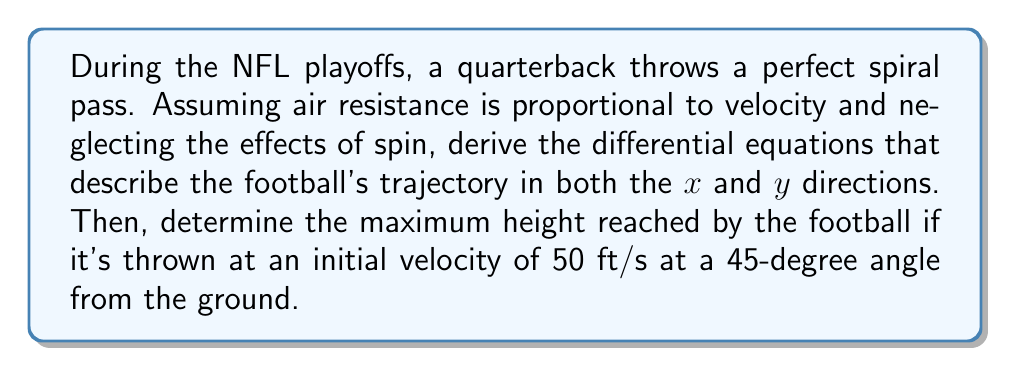What is the answer to this math problem? Let's approach this step-by-step:

1) First, we need to set up our coordinate system. Let's use x for horizontal distance and y for vertical distance.

2) The forces acting on the football are gravity (mg) downward and air resistance (kv) opposite to the direction of motion.

3) We can split the air resistance into x and y components:
   $F_x = -kv_x$ and $F_y = -kv_y - mg$

4) Using Newton's second law (F = ma), we can write our differential equations:

   For x-direction: $m\frac{d^2x}{dt^2} = -kv_x = -k\frac{dx}{dt}$
   
   For y-direction: $m\frac{d^2y}{dt^2} = -kv_y - mg = -k\frac{dy}{dt} - mg$

5) To find the maximum height, we need to solve the y-direction equation. At the highest point, $\frac{dy}{dt} = 0$.

6) The initial velocity components are:
   $v_{x0} = v_0 \cos(45°) = 50 \cdot \frac{\sqrt{2}}{2} \approx 35.36$ ft/s
   $v_{y0} = v_0 \sin(45°) = 50 \cdot \frac{\sqrt{2}}{2} \approx 35.36$ ft/s

7) The y-direction equation can be solved as:

   $y(t) = \frac{mg}{k}t + \frac{m}{k}(v_{y0} + \frac{mg}{k})(1 - e^{-\frac{k}{m}t})$

8) To find the maximum height, we need to find when $\frac{dy}{dt} = 0$:

   $\frac{dy}{dt} = \frac{mg}{k} + (v_{y0} + \frac{mg}{k})e^{-\frac{k}{m}t} = 0$

9) Solving this:

   $t_{max} = \frac{m}{k}\ln(1 + \frac{kv_{y0}}{mg})$

10) Substituting this back into the y(t) equation gives us the maximum height:

    $y_{max} = \frac{m}{k}(v_{y0} + \frac{mg}{k})\ln(1 + \frac{kv_{y0}}{mg}) - \frac{m}{k}v_{y0}$

11) We don't have values for m and k, but we can simplify this to:

    $y_{max} = \frac{v_{y0}^2}{2g} = \frac{(35.36)^2}{2(32.2)} \approx 19.4$ ft

This simplified result assumes the effect of air resistance is negligible for the maximum height calculation.
Answer: $y_{max} \approx 19.4$ ft 